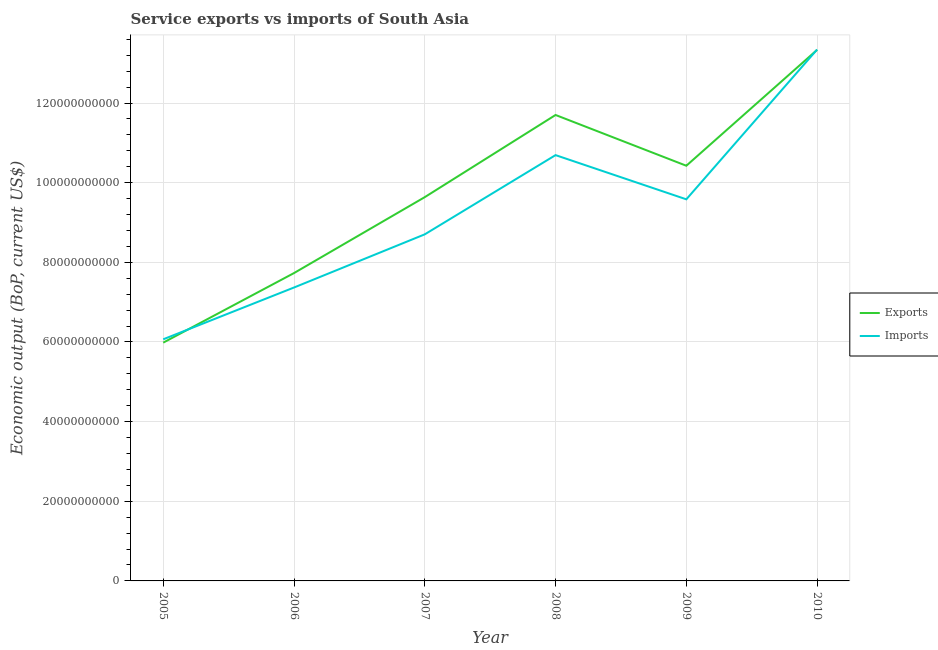How many different coloured lines are there?
Ensure brevity in your answer.  2. Does the line corresponding to amount of service imports intersect with the line corresponding to amount of service exports?
Ensure brevity in your answer.  Yes. Is the number of lines equal to the number of legend labels?
Provide a succinct answer. Yes. What is the amount of service imports in 2010?
Keep it short and to the point. 1.33e+11. Across all years, what is the maximum amount of service imports?
Keep it short and to the point. 1.33e+11. Across all years, what is the minimum amount of service exports?
Offer a terse response. 5.98e+1. In which year was the amount of service imports minimum?
Make the answer very short. 2005. What is the total amount of service imports in the graph?
Keep it short and to the point. 5.58e+11. What is the difference between the amount of service imports in 2005 and that in 2007?
Provide a short and direct response. -2.64e+1. What is the difference between the amount of service imports in 2006 and the amount of service exports in 2005?
Offer a terse response. 1.38e+1. What is the average amount of service imports per year?
Make the answer very short. 9.29e+1. In the year 2010, what is the difference between the amount of service exports and amount of service imports?
Provide a short and direct response. -8.23e+07. In how many years, is the amount of service imports greater than 48000000000 US$?
Keep it short and to the point. 6. What is the ratio of the amount of service imports in 2008 to that in 2009?
Offer a very short reply. 1.12. Is the difference between the amount of service exports in 2007 and 2009 greater than the difference between the amount of service imports in 2007 and 2009?
Keep it short and to the point. Yes. What is the difference between the highest and the second highest amount of service exports?
Your answer should be compact. 1.64e+1. What is the difference between the highest and the lowest amount of service imports?
Provide a succinct answer. 7.28e+1. In how many years, is the amount of service imports greater than the average amount of service imports taken over all years?
Your response must be concise. 3. Is the amount of service exports strictly less than the amount of service imports over the years?
Keep it short and to the point. No. What is the difference between two consecutive major ticks on the Y-axis?
Offer a terse response. 2.00e+1. Are the values on the major ticks of Y-axis written in scientific E-notation?
Keep it short and to the point. No. What is the title of the graph?
Ensure brevity in your answer.  Service exports vs imports of South Asia. Does "Female" appear as one of the legend labels in the graph?
Provide a succinct answer. No. What is the label or title of the X-axis?
Offer a terse response. Year. What is the label or title of the Y-axis?
Offer a very short reply. Economic output (BoP, current US$). What is the Economic output (BoP, current US$) of Exports in 2005?
Offer a very short reply. 5.98e+1. What is the Economic output (BoP, current US$) of Imports in 2005?
Ensure brevity in your answer.  6.07e+1. What is the Economic output (BoP, current US$) of Exports in 2006?
Your response must be concise. 7.73e+1. What is the Economic output (BoP, current US$) in Imports in 2006?
Make the answer very short. 7.37e+1. What is the Economic output (BoP, current US$) in Exports in 2007?
Offer a very short reply. 9.64e+1. What is the Economic output (BoP, current US$) of Imports in 2007?
Provide a succinct answer. 8.70e+1. What is the Economic output (BoP, current US$) of Exports in 2008?
Provide a short and direct response. 1.17e+11. What is the Economic output (BoP, current US$) of Imports in 2008?
Your response must be concise. 1.07e+11. What is the Economic output (BoP, current US$) in Exports in 2009?
Your response must be concise. 1.04e+11. What is the Economic output (BoP, current US$) of Imports in 2009?
Provide a succinct answer. 9.58e+1. What is the Economic output (BoP, current US$) of Exports in 2010?
Your response must be concise. 1.33e+11. What is the Economic output (BoP, current US$) in Imports in 2010?
Offer a very short reply. 1.33e+11. Across all years, what is the maximum Economic output (BoP, current US$) in Exports?
Provide a short and direct response. 1.33e+11. Across all years, what is the maximum Economic output (BoP, current US$) of Imports?
Offer a terse response. 1.33e+11. Across all years, what is the minimum Economic output (BoP, current US$) of Exports?
Ensure brevity in your answer.  5.98e+1. Across all years, what is the minimum Economic output (BoP, current US$) in Imports?
Ensure brevity in your answer.  6.07e+1. What is the total Economic output (BoP, current US$) of Exports in the graph?
Provide a short and direct response. 5.88e+11. What is the total Economic output (BoP, current US$) in Imports in the graph?
Ensure brevity in your answer.  5.58e+11. What is the difference between the Economic output (BoP, current US$) in Exports in 2005 and that in 2006?
Ensure brevity in your answer.  -1.75e+1. What is the difference between the Economic output (BoP, current US$) in Imports in 2005 and that in 2006?
Make the answer very short. -1.30e+1. What is the difference between the Economic output (BoP, current US$) of Exports in 2005 and that in 2007?
Your answer should be very brief. -3.65e+1. What is the difference between the Economic output (BoP, current US$) of Imports in 2005 and that in 2007?
Keep it short and to the point. -2.64e+1. What is the difference between the Economic output (BoP, current US$) of Exports in 2005 and that in 2008?
Give a very brief answer. -5.72e+1. What is the difference between the Economic output (BoP, current US$) of Imports in 2005 and that in 2008?
Offer a very short reply. -4.63e+1. What is the difference between the Economic output (BoP, current US$) of Exports in 2005 and that in 2009?
Provide a short and direct response. -4.44e+1. What is the difference between the Economic output (BoP, current US$) of Imports in 2005 and that in 2009?
Keep it short and to the point. -3.52e+1. What is the difference between the Economic output (BoP, current US$) in Exports in 2005 and that in 2010?
Keep it short and to the point. -7.35e+1. What is the difference between the Economic output (BoP, current US$) of Imports in 2005 and that in 2010?
Provide a succinct answer. -7.28e+1. What is the difference between the Economic output (BoP, current US$) of Exports in 2006 and that in 2007?
Your response must be concise. -1.91e+1. What is the difference between the Economic output (BoP, current US$) of Imports in 2006 and that in 2007?
Keep it short and to the point. -1.34e+1. What is the difference between the Economic output (BoP, current US$) in Exports in 2006 and that in 2008?
Your response must be concise. -3.97e+1. What is the difference between the Economic output (BoP, current US$) in Imports in 2006 and that in 2008?
Offer a terse response. -3.32e+1. What is the difference between the Economic output (BoP, current US$) in Exports in 2006 and that in 2009?
Provide a succinct answer. -2.70e+1. What is the difference between the Economic output (BoP, current US$) of Imports in 2006 and that in 2009?
Your answer should be compact. -2.21e+1. What is the difference between the Economic output (BoP, current US$) of Exports in 2006 and that in 2010?
Provide a succinct answer. -5.61e+1. What is the difference between the Economic output (BoP, current US$) in Imports in 2006 and that in 2010?
Offer a very short reply. -5.98e+1. What is the difference between the Economic output (BoP, current US$) of Exports in 2007 and that in 2008?
Offer a terse response. -2.06e+1. What is the difference between the Economic output (BoP, current US$) in Imports in 2007 and that in 2008?
Make the answer very short. -1.99e+1. What is the difference between the Economic output (BoP, current US$) in Exports in 2007 and that in 2009?
Give a very brief answer. -7.88e+09. What is the difference between the Economic output (BoP, current US$) of Imports in 2007 and that in 2009?
Keep it short and to the point. -8.79e+09. What is the difference between the Economic output (BoP, current US$) of Exports in 2007 and that in 2010?
Provide a succinct answer. -3.70e+1. What is the difference between the Economic output (BoP, current US$) of Imports in 2007 and that in 2010?
Offer a terse response. -4.64e+1. What is the difference between the Economic output (BoP, current US$) in Exports in 2008 and that in 2009?
Your answer should be compact. 1.27e+1. What is the difference between the Economic output (BoP, current US$) of Imports in 2008 and that in 2009?
Your answer should be very brief. 1.11e+1. What is the difference between the Economic output (BoP, current US$) in Exports in 2008 and that in 2010?
Provide a short and direct response. -1.64e+1. What is the difference between the Economic output (BoP, current US$) in Imports in 2008 and that in 2010?
Your response must be concise. -2.65e+1. What is the difference between the Economic output (BoP, current US$) in Exports in 2009 and that in 2010?
Keep it short and to the point. -2.91e+1. What is the difference between the Economic output (BoP, current US$) in Imports in 2009 and that in 2010?
Your response must be concise. -3.76e+1. What is the difference between the Economic output (BoP, current US$) in Exports in 2005 and the Economic output (BoP, current US$) in Imports in 2006?
Your response must be concise. -1.38e+1. What is the difference between the Economic output (BoP, current US$) in Exports in 2005 and the Economic output (BoP, current US$) in Imports in 2007?
Provide a succinct answer. -2.72e+1. What is the difference between the Economic output (BoP, current US$) of Exports in 2005 and the Economic output (BoP, current US$) of Imports in 2008?
Provide a short and direct response. -4.71e+1. What is the difference between the Economic output (BoP, current US$) in Exports in 2005 and the Economic output (BoP, current US$) in Imports in 2009?
Your response must be concise. -3.60e+1. What is the difference between the Economic output (BoP, current US$) in Exports in 2005 and the Economic output (BoP, current US$) in Imports in 2010?
Your response must be concise. -7.36e+1. What is the difference between the Economic output (BoP, current US$) of Exports in 2006 and the Economic output (BoP, current US$) of Imports in 2007?
Keep it short and to the point. -9.73e+09. What is the difference between the Economic output (BoP, current US$) of Exports in 2006 and the Economic output (BoP, current US$) of Imports in 2008?
Offer a terse response. -2.96e+1. What is the difference between the Economic output (BoP, current US$) of Exports in 2006 and the Economic output (BoP, current US$) of Imports in 2009?
Make the answer very short. -1.85e+1. What is the difference between the Economic output (BoP, current US$) of Exports in 2006 and the Economic output (BoP, current US$) of Imports in 2010?
Ensure brevity in your answer.  -5.61e+1. What is the difference between the Economic output (BoP, current US$) of Exports in 2007 and the Economic output (BoP, current US$) of Imports in 2008?
Ensure brevity in your answer.  -1.05e+1. What is the difference between the Economic output (BoP, current US$) in Exports in 2007 and the Economic output (BoP, current US$) in Imports in 2009?
Your answer should be compact. 5.49e+08. What is the difference between the Economic output (BoP, current US$) in Exports in 2007 and the Economic output (BoP, current US$) in Imports in 2010?
Provide a succinct answer. -3.71e+1. What is the difference between the Economic output (BoP, current US$) of Exports in 2008 and the Economic output (BoP, current US$) of Imports in 2009?
Provide a succinct answer. 2.12e+1. What is the difference between the Economic output (BoP, current US$) in Exports in 2008 and the Economic output (BoP, current US$) in Imports in 2010?
Ensure brevity in your answer.  -1.64e+1. What is the difference between the Economic output (BoP, current US$) of Exports in 2009 and the Economic output (BoP, current US$) of Imports in 2010?
Ensure brevity in your answer.  -2.92e+1. What is the average Economic output (BoP, current US$) of Exports per year?
Your answer should be very brief. 9.80e+1. What is the average Economic output (BoP, current US$) in Imports per year?
Your answer should be very brief. 9.29e+1. In the year 2005, what is the difference between the Economic output (BoP, current US$) of Exports and Economic output (BoP, current US$) of Imports?
Keep it short and to the point. -8.40e+08. In the year 2006, what is the difference between the Economic output (BoP, current US$) in Exports and Economic output (BoP, current US$) in Imports?
Your response must be concise. 3.63e+09. In the year 2007, what is the difference between the Economic output (BoP, current US$) of Exports and Economic output (BoP, current US$) of Imports?
Your response must be concise. 9.34e+09. In the year 2008, what is the difference between the Economic output (BoP, current US$) in Exports and Economic output (BoP, current US$) in Imports?
Your response must be concise. 1.01e+1. In the year 2009, what is the difference between the Economic output (BoP, current US$) in Exports and Economic output (BoP, current US$) in Imports?
Provide a succinct answer. 8.43e+09. In the year 2010, what is the difference between the Economic output (BoP, current US$) in Exports and Economic output (BoP, current US$) in Imports?
Make the answer very short. -8.23e+07. What is the ratio of the Economic output (BoP, current US$) of Exports in 2005 to that in 2006?
Offer a very short reply. 0.77. What is the ratio of the Economic output (BoP, current US$) in Imports in 2005 to that in 2006?
Your answer should be compact. 0.82. What is the ratio of the Economic output (BoP, current US$) of Exports in 2005 to that in 2007?
Provide a short and direct response. 0.62. What is the ratio of the Economic output (BoP, current US$) of Imports in 2005 to that in 2007?
Your response must be concise. 0.7. What is the ratio of the Economic output (BoP, current US$) in Exports in 2005 to that in 2008?
Your answer should be compact. 0.51. What is the ratio of the Economic output (BoP, current US$) of Imports in 2005 to that in 2008?
Keep it short and to the point. 0.57. What is the ratio of the Economic output (BoP, current US$) in Exports in 2005 to that in 2009?
Provide a succinct answer. 0.57. What is the ratio of the Economic output (BoP, current US$) in Imports in 2005 to that in 2009?
Provide a succinct answer. 0.63. What is the ratio of the Economic output (BoP, current US$) in Exports in 2005 to that in 2010?
Give a very brief answer. 0.45. What is the ratio of the Economic output (BoP, current US$) of Imports in 2005 to that in 2010?
Ensure brevity in your answer.  0.45. What is the ratio of the Economic output (BoP, current US$) in Exports in 2006 to that in 2007?
Your answer should be very brief. 0.8. What is the ratio of the Economic output (BoP, current US$) of Imports in 2006 to that in 2007?
Offer a terse response. 0.85. What is the ratio of the Economic output (BoP, current US$) in Exports in 2006 to that in 2008?
Your answer should be compact. 0.66. What is the ratio of the Economic output (BoP, current US$) of Imports in 2006 to that in 2008?
Ensure brevity in your answer.  0.69. What is the ratio of the Economic output (BoP, current US$) of Exports in 2006 to that in 2009?
Ensure brevity in your answer.  0.74. What is the ratio of the Economic output (BoP, current US$) in Imports in 2006 to that in 2009?
Provide a succinct answer. 0.77. What is the ratio of the Economic output (BoP, current US$) in Exports in 2006 to that in 2010?
Offer a very short reply. 0.58. What is the ratio of the Economic output (BoP, current US$) in Imports in 2006 to that in 2010?
Ensure brevity in your answer.  0.55. What is the ratio of the Economic output (BoP, current US$) in Exports in 2007 to that in 2008?
Offer a terse response. 0.82. What is the ratio of the Economic output (BoP, current US$) in Imports in 2007 to that in 2008?
Provide a succinct answer. 0.81. What is the ratio of the Economic output (BoP, current US$) in Exports in 2007 to that in 2009?
Your answer should be very brief. 0.92. What is the ratio of the Economic output (BoP, current US$) of Imports in 2007 to that in 2009?
Keep it short and to the point. 0.91. What is the ratio of the Economic output (BoP, current US$) in Exports in 2007 to that in 2010?
Offer a terse response. 0.72. What is the ratio of the Economic output (BoP, current US$) of Imports in 2007 to that in 2010?
Offer a very short reply. 0.65. What is the ratio of the Economic output (BoP, current US$) in Exports in 2008 to that in 2009?
Ensure brevity in your answer.  1.12. What is the ratio of the Economic output (BoP, current US$) in Imports in 2008 to that in 2009?
Give a very brief answer. 1.12. What is the ratio of the Economic output (BoP, current US$) of Exports in 2008 to that in 2010?
Your answer should be very brief. 0.88. What is the ratio of the Economic output (BoP, current US$) in Imports in 2008 to that in 2010?
Your answer should be compact. 0.8. What is the ratio of the Economic output (BoP, current US$) in Exports in 2009 to that in 2010?
Your answer should be very brief. 0.78. What is the ratio of the Economic output (BoP, current US$) in Imports in 2009 to that in 2010?
Offer a terse response. 0.72. What is the difference between the highest and the second highest Economic output (BoP, current US$) of Exports?
Ensure brevity in your answer.  1.64e+1. What is the difference between the highest and the second highest Economic output (BoP, current US$) in Imports?
Offer a very short reply. 2.65e+1. What is the difference between the highest and the lowest Economic output (BoP, current US$) of Exports?
Your answer should be compact. 7.35e+1. What is the difference between the highest and the lowest Economic output (BoP, current US$) in Imports?
Keep it short and to the point. 7.28e+1. 